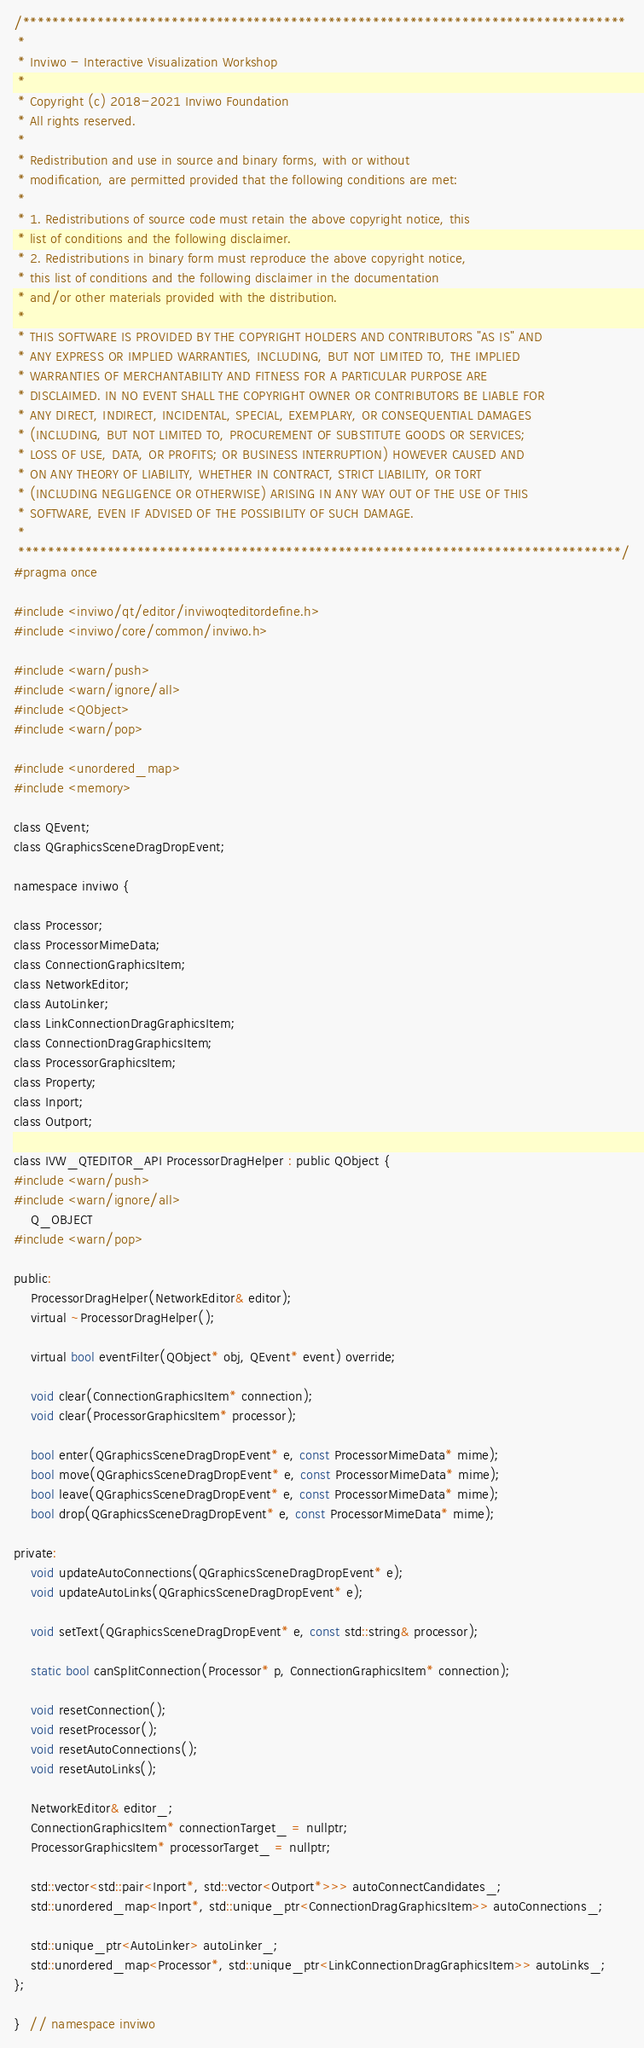Convert code to text. <code><loc_0><loc_0><loc_500><loc_500><_C_>/*********************************************************************************
 *
 * Inviwo - Interactive Visualization Workshop
 *
 * Copyright (c) 2018-2021 Inviwo Foundation
 * All rights reserved.
 *
 * Redistribution and use in source and binary forms, with or without
 * modification, are permitted provided that the following conditions are met:
 *
 * 1. Redistributions of source code must retain the above copyright notice, this
 * list of conditions and the following disclaimer.
 * 2. Redistributions in binary form must reproduce the above copyright notice,
 * this list of conditions and the following disclaimer in the documentation
 * and/or other materials provided with the distribution.
 *
 * THIS SOFTWARE IS PROVIDED BY THE COPYRIGHT HOLDERS AND CONTRIBUTORS "AS IS" AND
 * ANY EXPRESS OR IMPLIED WARRANTIES, INCLUDING, BUT NOT LIMITED TO, THE IMPLIED
 * WARRANTIES OF MERCHANTABILITY AND FITNESS FOR A PARTICULAR PURPOSE ARE
 * DISCLAIMED. IN NO EVENT SHALL THE COPYRIGHT OWNER OR CONTRIBUTORS BE LIABLE FOR
 * ANY DIRECT, INDIRECT, INCIDENTAL, SPECIAL, EXEMPLARY, OR CONSEQUENTIAL DAMAGES
 * (INCLUDING, BUT NOT LIMITED TO, PROCUREMENT OF SUBSTITUTE GOODS OR SERVICES;
 * LOSS OF USE, DATA, OR PROFITS; OR BUSINESS INTERRUPTION) HOWEVER CAUSED AND
 * ON ANY THEORY OF LIABILITY, WHETHER IN CONTRACT, STRICT LIABILITY, OR TORT
 * (INCLUDING NEGLIGENCE OR OTHERWISE) ARISING IN ANY WAY OUT OF THE USE OF THIS
 * SOFTWARE, EVEN IF ADVISED OF THE POSSIBILITY OF SUCH DAMAGE.
 *
 *********************************************************************************/
#pragma once

#include <inviwo/qt/editor/inviwoqteditordefine.h>
#include <inviwo/core/common/inviwo.h>

#include <warn/push>
#include <warn/ignore/all>
#include <QObject>
#include <warn/pop>

#include <unordered_map>
#include <memory>

class QEvent;
class QGraphicsSceneDragDropEvent;

namespace inviwo {

class Processor;
class ProcessorMimeData;
class ConnectionGraphicsItem;
class NetworkEditor;
class AutoLinker;
class LinkConnectionDragGraphicsItem;
class ConnectionDragGraphicsItem;
class ProcessorGraphicsItem;
class Property;
class Inport;
class Outport;

class IVW_QTEDITOR_API ProcessorDragHelper : public QObject {
#include <warn/push>
#include <warn/ignore/all>
    Q_OBJECT
#include <warn/pop>

public:
    ProcessorDragHelper(NetworkEditor& editor);
    virtual ~ProcessorDragHelper();

    virtual bool eventFilter(QObject* obj, QEvent* event) override;

    void clear(ConnectionGraphicsItem* connection);
    void clear(ProcessorGraphicsItem* processor);

    bool enter(QGraphicsSceneDragDropEvent* e, const ProcessorMimeData* mime);
    bool move(QGraphicsSceneDragDropEvent* e, const ProcessorMimeData* mime);
    bool leave(QGraphicsSceneDragDropEvent* e, const ProcessorMimeData* mime);
    bool drop(QGraphicsSceneDragDropEvent* e, const ProcessorMimeData* mime);

private:
    void updateAutoConnections(QGraphicsSceneDragDropEvent* e);
    void updateAutoLinks(QGraphicsSceneDragDropEvent* e);

    void setText(QGraphicsSceneDragDropEvent* e, const std::string& processor);

    static bool canSplitConnection(Processor* p, ConnectionGraphicsItem* connection);

    void resetConnection();
    void resetProcessor();
    void resetAutoConnections();
    void resetAutoLinks();

    NetworkEditor& editor_;
    ConnectionGraphicsItem* connectionTarget_ = nullptr;
    ProcessorGraphicsItem* processorTarget_ = nullptr;

    std::vector<std::pair<Inport*, std::vector<Outport*>>> autoConnectCandidates_;
    std::unordered_map<Inport*, std::unique_ptr<ConnectionDragGraphicsItem>> autoConnections_;

    std::unique_ptr<AutoLinker> autoLinker_;
    std::unordered_map<Processor*, std::unique_ptr<LinkConnectionDragGraphicsItem>> autoLinks_;
};

}  // namespace inviwo
</code> 